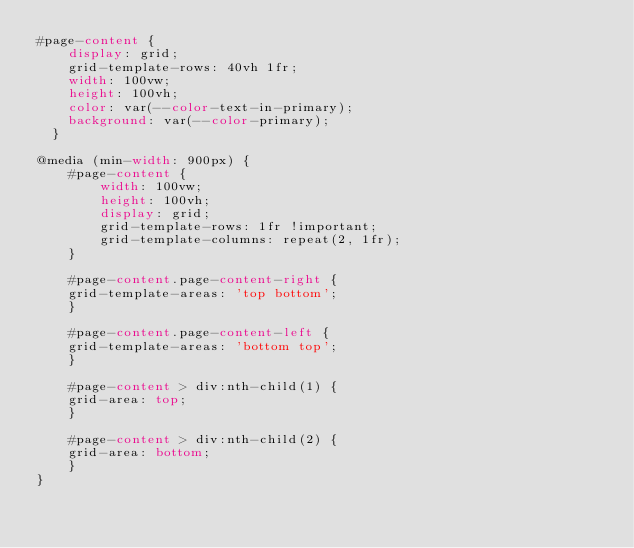Convert code to text. <code><loc_0><loc_0><loc_500><loc_500><_CSS_>#page-content {
    display: grid;
    grid-template-rows: 40vh 1fr;
    width: 100vw;
    height: 100vh;
    color: var(--color-text-in-primary);
    background: var(--color-primary);
  }
  
@media (min-width: 900px) {
    #page-content {
        width: 100vw;
        height: 100vh;
        display: grid;
        grid-template-rows: 1fr !important;
        grid-template-columns: repeat(2, 1fr);
    }

    #page-content.page-content-right {
    grid-template-areas: 'top bottom';
    }

    #page-content.page-content-left {
    grid-template-areas: 'bottom top';
    }

    #page-content > div:nth-child(1) {
    grid-area: top;
    }

    #page-content > div:nth-child(2) {
    grid-area: bottom;
    }
}
</code> 